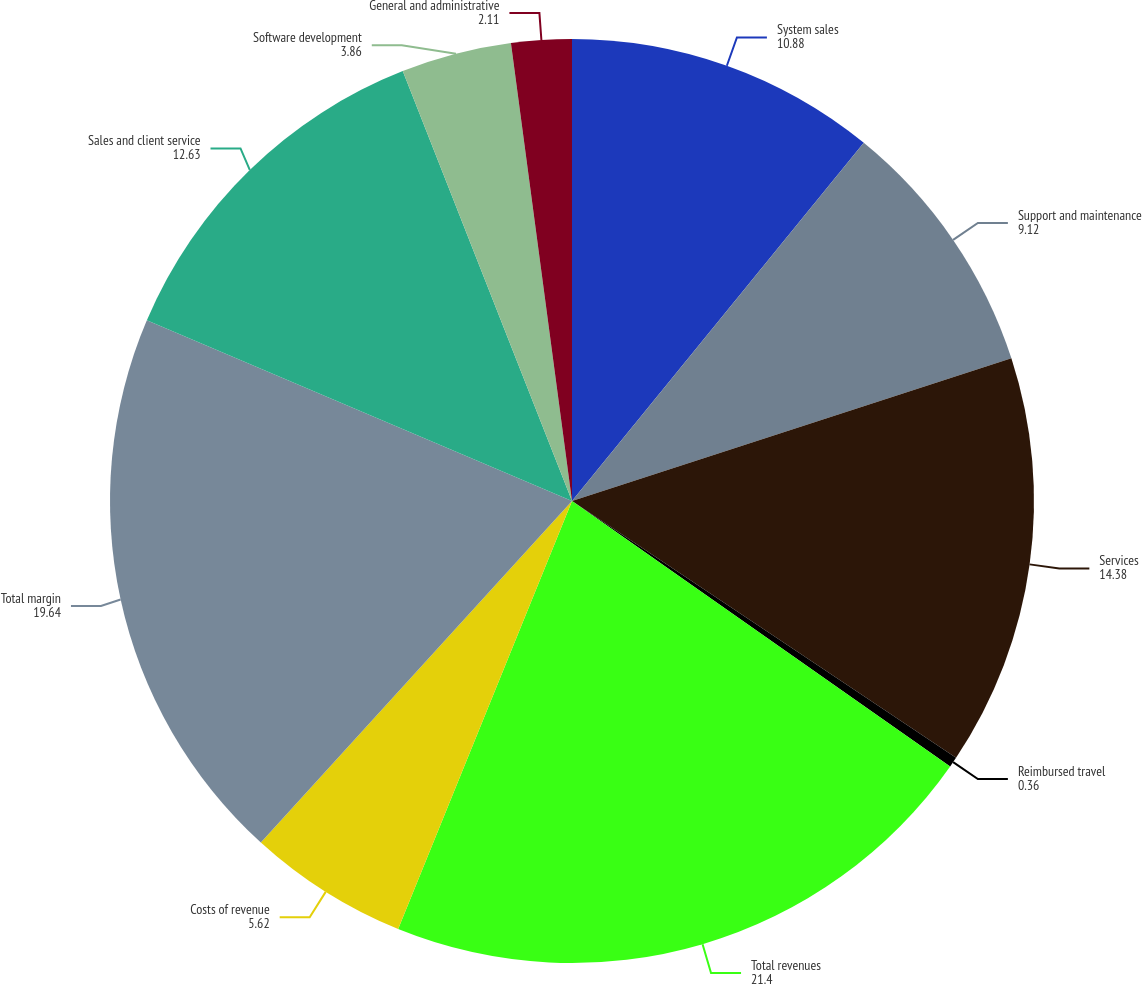Convert chart to OTSL. <chart><loc_0><loc_0><loc_500><loc_500><pie_chart><fcel>System sales<fcel>Support and maintenance<fcel>Services<fcel>Reimbursed travel<fcel>Total revenues<fcel>Costs of revenue<fcel>Total margin<fcel>Sales and client service<fcel>Software development<fcel>General and administrative<nl><fcel>10.88%<fcel>9.12%<fcel>14.38%<fcel>0.36%<fcel>21.4%<fcel>5.62%<fcel>19.64%<fcel>12.63%<fcel>3.86%<fcel>2.11%<nl></chart> 